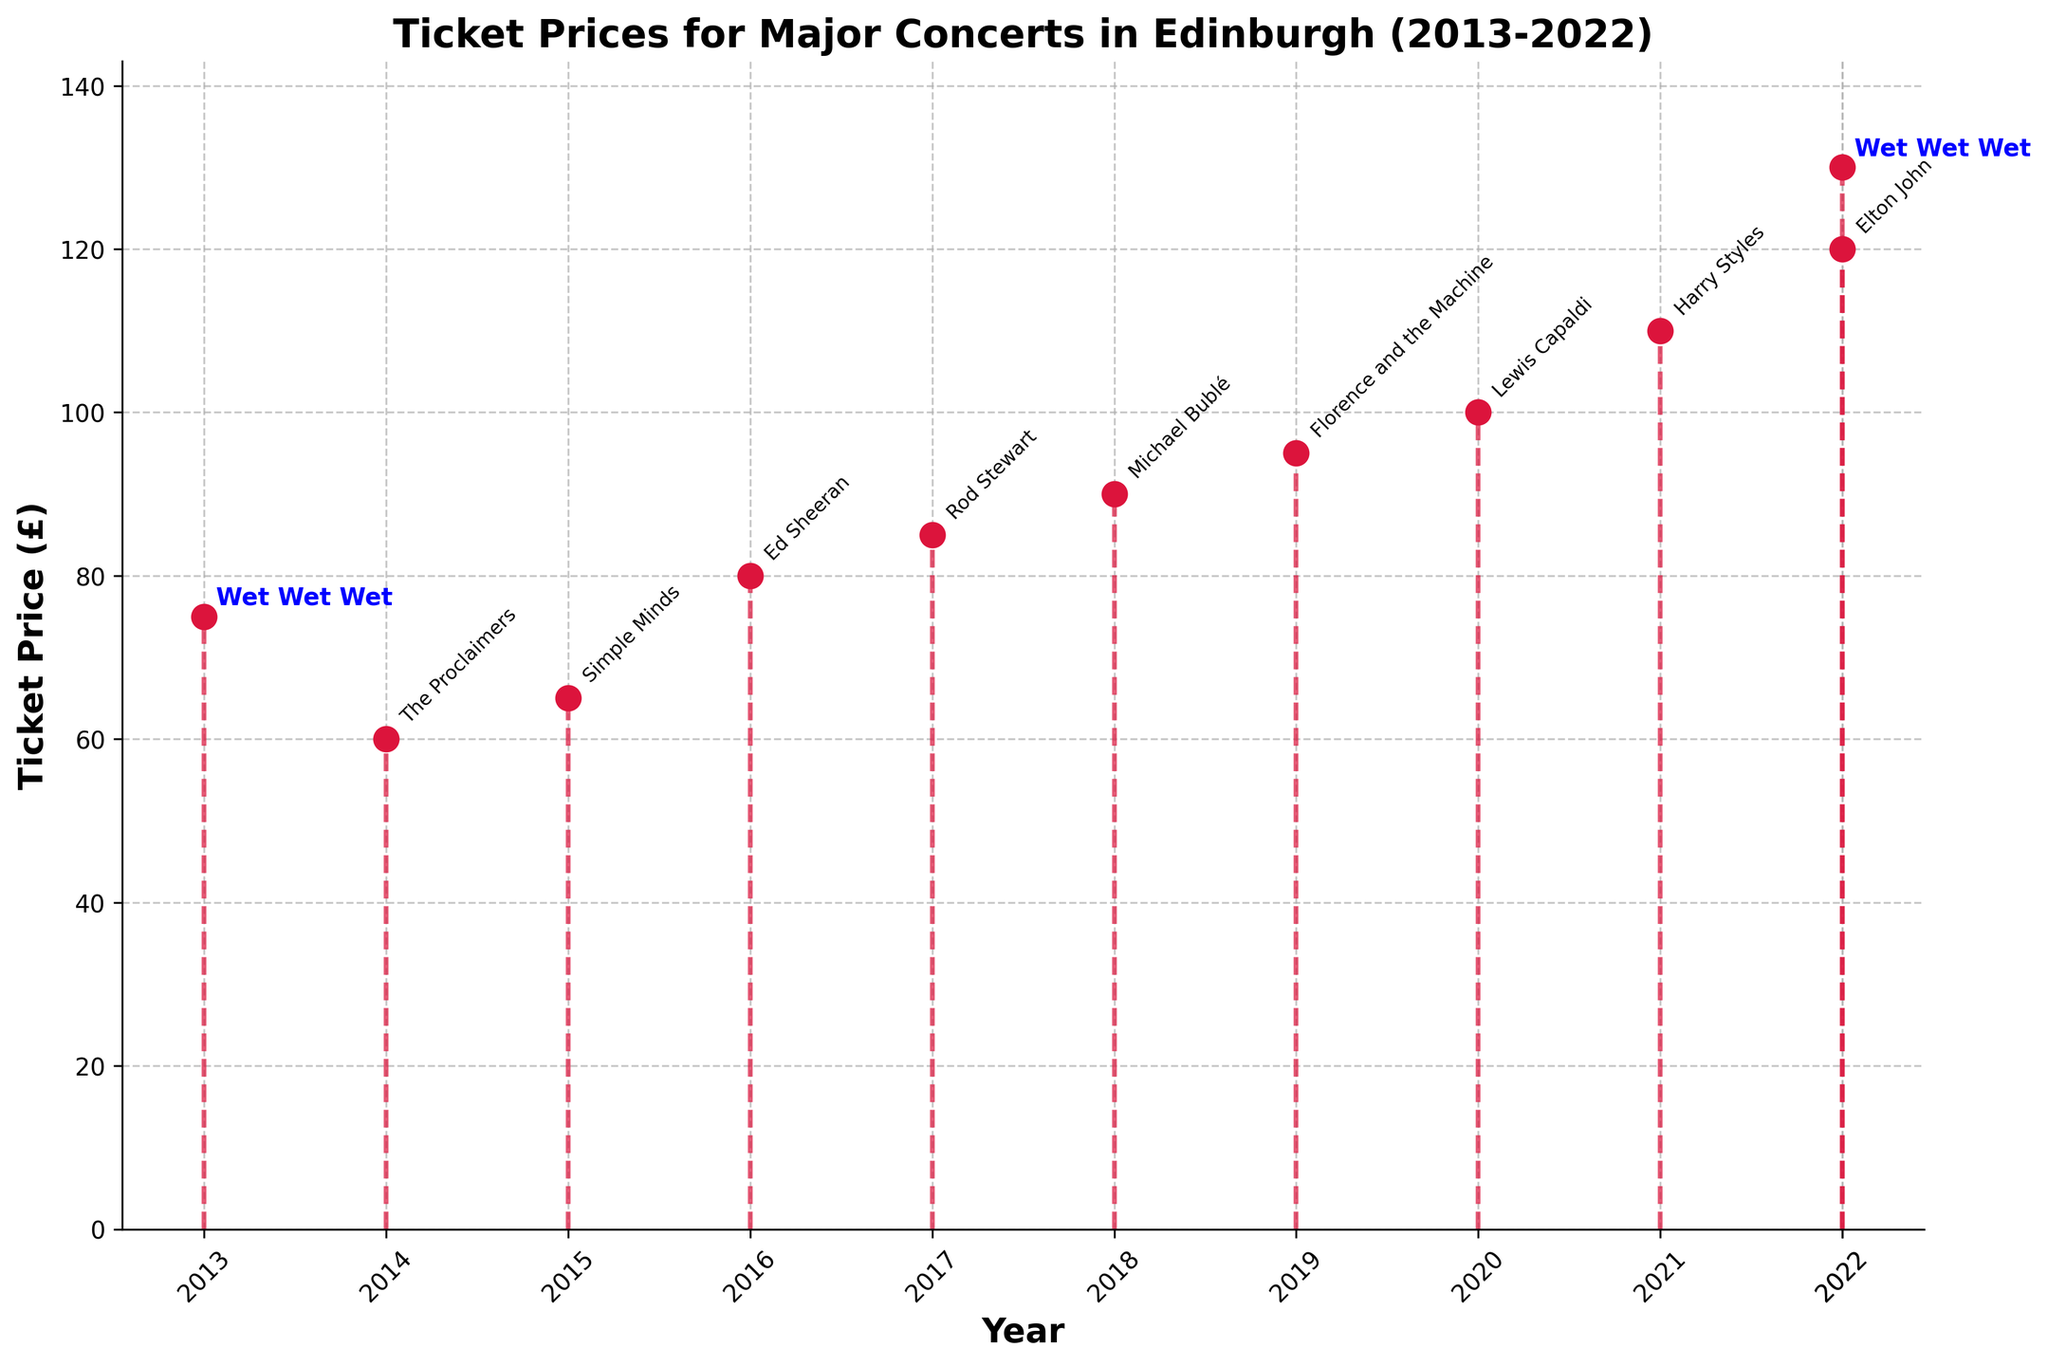What's the title of the figure? The title of the figure is generally displayed at the top of the plot. Here, it reads 'Ticket Prices for Major Concerts in Edinburgh (2013-2022)' based on the code.
Answer: Ticket Prices for Major Concerts in Edinburgh (2013-2022) What is the ticket price for Ed Sheeran's concert? Locate the 'Ed Sheeran' label in the chart and trace it to its corresponding year and price. It shows a price of £80 for the year 2016.
Answer: £80 In which year was the ticket price the highest? Compare the heights of the lines on the y-axis to find the tallest stem. The highest value in the plot corresponds to 'Wet Wet Wet' in the year 2022, with a ticket price of £130.
Answer: 2022 How many concerts had ticket prices over £100? Identify and count the stems above the £100 mark on the y-axis. There are three such concerts: Lewis Capaldi (2020), Harry Styles (2021), and Wet Wet Wet (2022).
Answer: 3 Which concert had the lowest ticket price? Compare the heights of the stems to see which one is the shortest. 'The Proclaimers' in 2014 has the lowest ticket price of £60.
Answer: The Proclaimers What is the total ticket price for both Wet Wet Wet concerts? Find the ticket prices for Wet Wet Wet in 2013 and 2022, which are £75 and £130 respectively. Add them together for a total of £205.
Answer: £205 By how much did the ticket price for Wet Wet Wet increase from 2013 to 2022? Subtract the ticket price in 2013 (£75) from the ticket price in 2022 (£130). The difference is £130 - £75 = £55.
Answer: £55 Which concerts had ticket prices exactly equal to or more than £90? Identify the stems that reach at least £90 on the y-axis. These concerts are Michael Bublé (2018), Florence and the Machine (2019), Lewis Capaldi (2020), Harry Styles (2021), Elton John (2022), and Wet Wet Wet (2022).
Answer: 6 What is the average ticket price of the concerts over the last decade? Sum the ticket prices and divide by the total number of concerts. The sum is £75 + £60 + £65 + £80 + £85 + £90 + £95 + £100 + £110 + £120 + £130 = £1010. The average is £1010 / 11 ≈ £91.82.
Answer: £91.82 Which year had the biggest increase in ticket price compared to its previous year? Look for the year-to-year changes and find the largest difference. The biggest increase is from Elton John (2022), £120, to Wet Wet Wet (2022), £130, an increase of £10.
Answer: 2022 